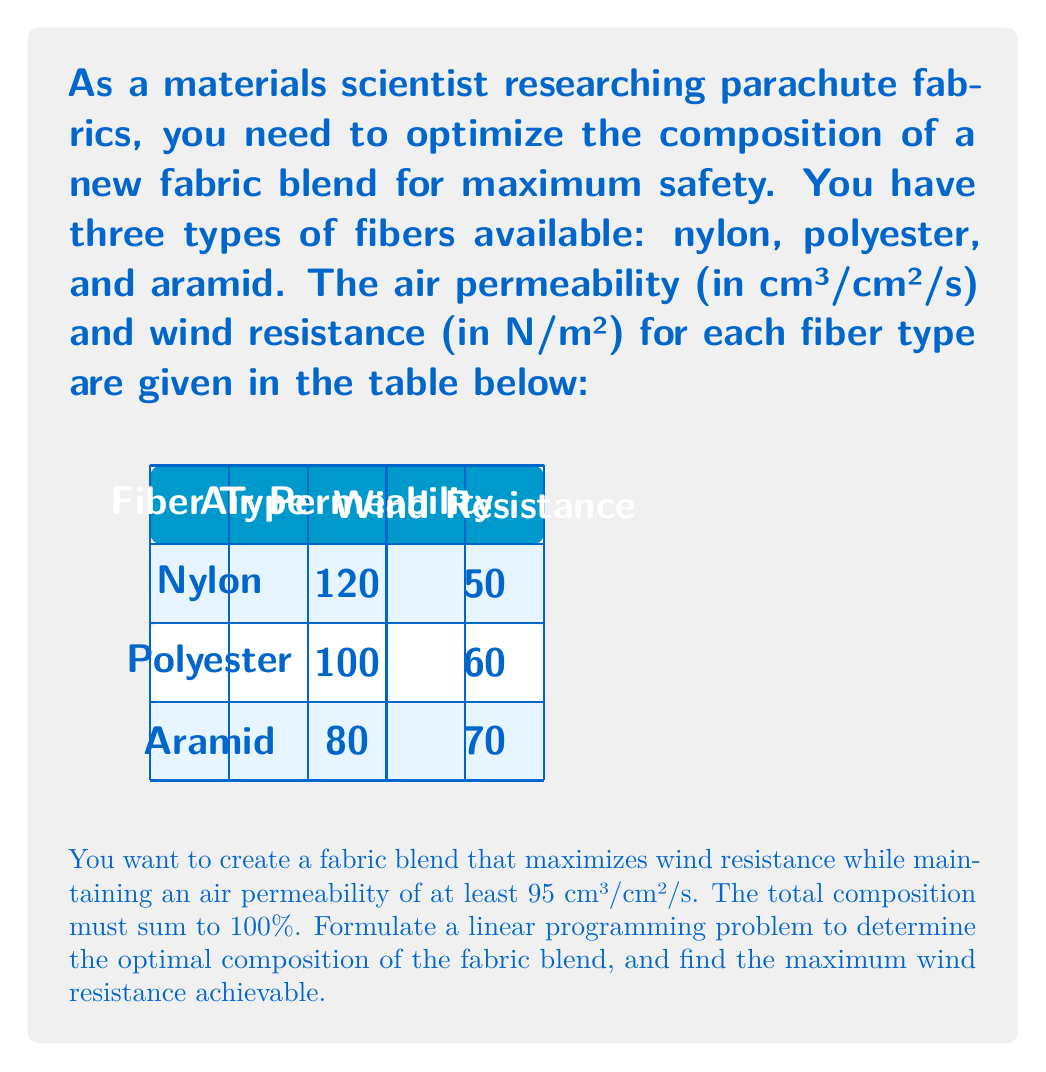Solve this math problem. Let's approach this step-by-step:

1) Define variables:
   Let $x_1$, $x_2$, and $x_3$ represent the percentages of nylon, polyester, and aramid in the blend, respectively.

2) Objective function:
   We want to maximize wind resistance. The wind resistance of the blend will be the sum of each fiber's contribution:
   Maximize $Z = 50x_1 + 60x_2 + 70x_3$

3) Constraints:
   a) Air permeability constraint:
      $120x_1 + 100x_2 + 80x_3 \geq 95$
   
   b) Composition constraint (must sum to 100%):
      $x_1 + x_2 + x_3 = 1$ (we use 1 instead of 100 for simplicity)
   
   c) Non-negativity constraints:
      $x_1 \geq 0$, $x_2 \geq 0$, $x_3 \geq 0$

4) Complete linear programming formulation:
   Maximize $Z = 50x_1 + 60x_2 + 70x_3$
   Subject to:
   $120x_1 + 100x_2 + 80x_3 \geq 95$
   $x_1 + x_2 + x_3 = 1$
   $x_1, x_2, x_3 \geq 0$

5) Solve using the simplex method or linear programming software.

6) The optimal solution is:
   $x_1 = 0.1875$ (18.75% nylon)
   $x_2 = 0$ (0% polyester)
   $x_3 = 0.8125$ (81.25% aramid)

7) The maximum wind resistance achieved is:
   $Z = 50(0.1875) + 60(0) + 70(0.8125) = 66.25$ N/m²

Therefore, the optimal fabric blend consists of 18.75% nylon and 81.25% aramid, achieving a maximum wind resistance of 66.25 N/m².
Answer: 66.25 N/m² 